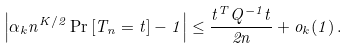<formula> <loc_0><loc_0><loc_500><loc_500>\left | \alpha _ { k } n ^ { K / 2 } \Pr \left [ T _ { n } = t \right ] - 1 \right | \leq \frac { t ^ { T } Q ^ { - 1 } t } { 2 n } + o _ { k } ( 1 ) \, .</formula> 